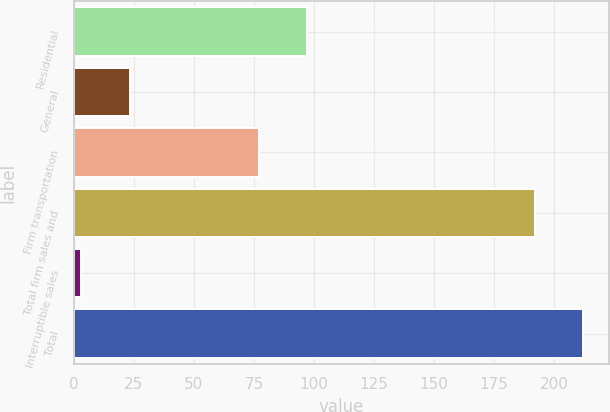Convert chart. <chart><loc_0><loc_0><loc_500><loc_500><bar_chart><fcel>Residential<fcel>General<fcel>Firm transportation<fcel>Total firm sales and<fcel>Interruptible sales<fcel>Total<nl><fcel>97.2<fcel>23.2<fcel>77<fcel>192<fcel>3<fcel>212.2<nl></chart> 